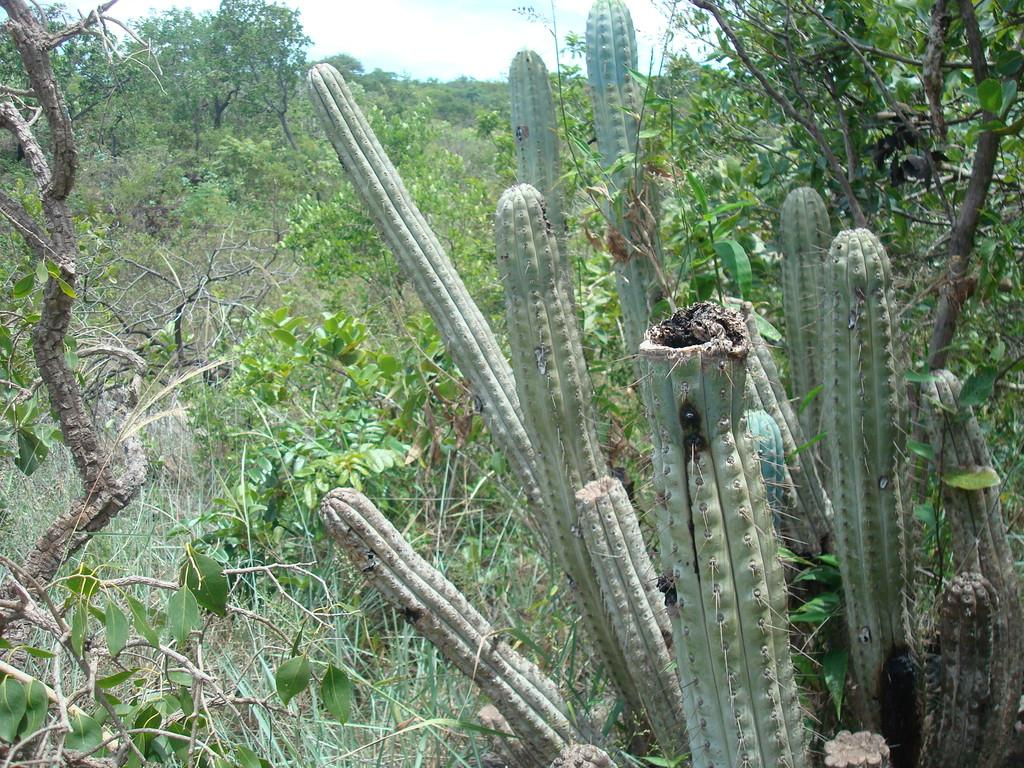What type of natural environment is depicted in the image? The image contains a forest. What are the main features of the forest? There are trees and plants in the forest. What can be seen in the sky in the image? The sky is visible at the top of the image. What color is the orange on the van in the image? There is no orange or van present in the image; it features a forest with trees and plants. 